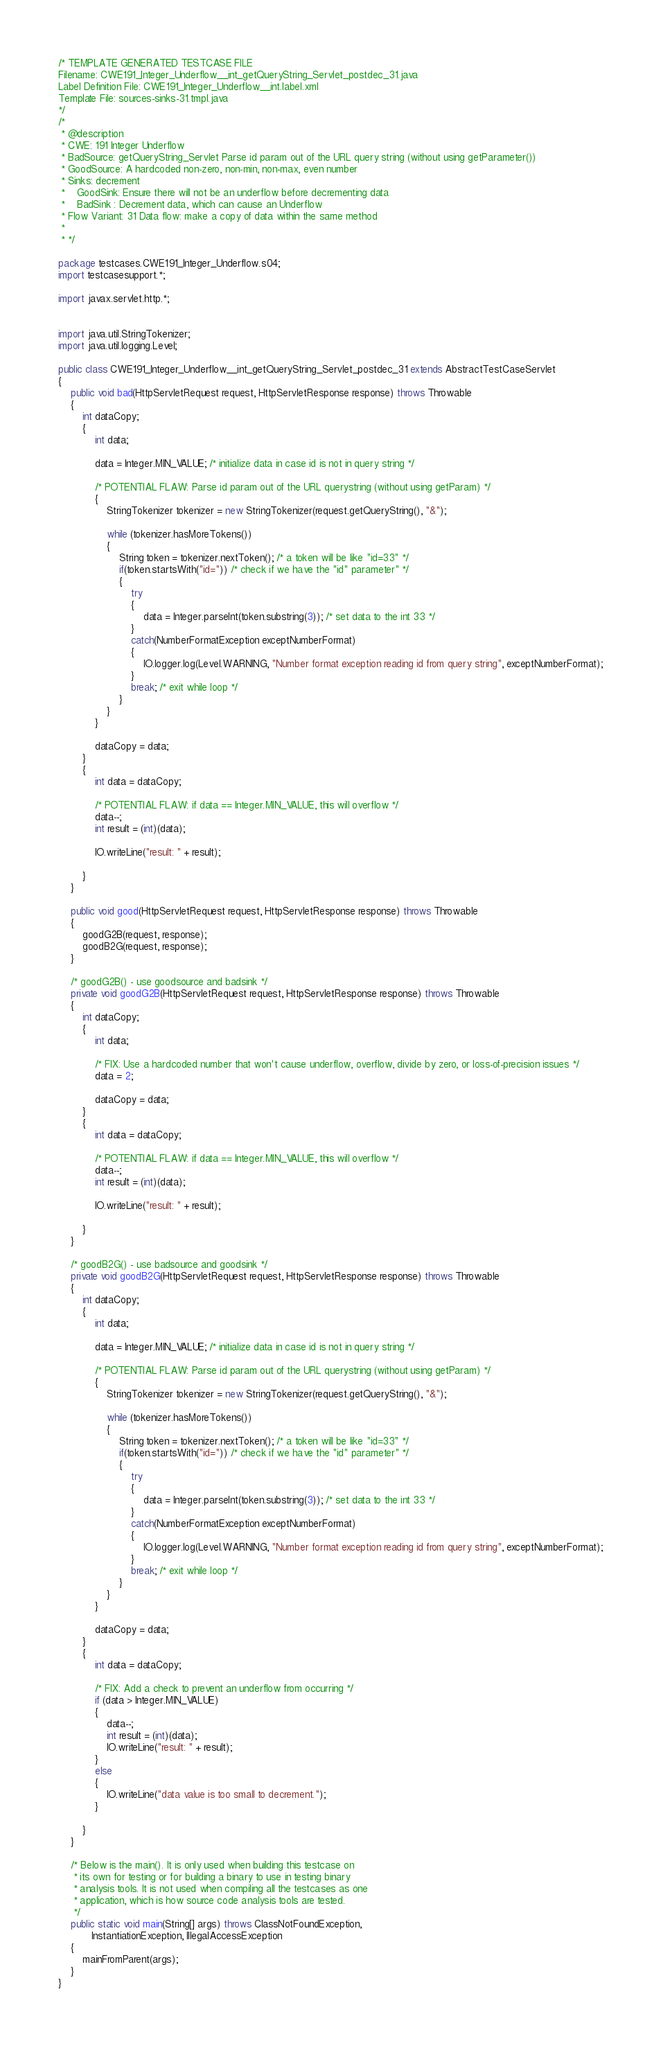<code> <loc_0><loc_0><loc_500><loc_500><_Java_>/* TEMPLATE GENERATED TESTCASE FILE
Filename: CWE191_Integer_Underflow__int_getQueryString_Servlet_postdec_31.java
Label Definition File: CWE191_Integer_Underflow__int.label.xml
Template File: sources-sinks-31.tmpl.java
*/
/*
 * @description
 * CWE: 191 Integer Underflow
 * BadSource: getQueryString_Servlet Parse id param out of the URL query string (without using getParameter())
 * GoodSource: A hardcoded non-zero, non-min, non-max, even number
 * Sinks: decrement
 *    GoodSink: Ensure there will not be an underflow before decrementing data
 *    BadSink : Decrement data, which can cause an Underflow
 * Flow Variant: 31 Data flow: make a copy of data within the same method
 *
 * */

package testcases.CWE191_Integer_Underflow.s04;
import testcasesupport.*;

import javax.servlet.http.*;


import java.util.StringTokenizer;
import java.util.logging.Level;

public class CWE191_Integer_Underflow__int_getQueryString_Servlet_postdec_31 extends AbstractTestCaseServlet
{
    public void bad(HttpServletRequest request, HttpServletResponse response) throws Throwable
    {
        int dataCopy;
        {
            int data;

            data = Integer.MIN_VALUE; /* initialize data in case id is not in query string */

            /* POTENTIAL FLAW: Parse id param out of the URL querystring (without using getParam) */
            {
                StringTokenizer tokenizer = new StringTokenizer(request.getQueryString(), "&");

                while (tokenizer.hasMoreTokens())
                {
                    String token = tokenizer.nextToken(); /* a token will be like "id=33" */
                    if(token.startsWith("id=")) /* check if we have the "id" parameter" */
                    {
                        try
                        {
                            data = Integer.parseInt(token.substring(3)); /* set data to the int 33 */
                        }
                        catch(NumberFormatException exceptNumberFormat)
                        {
                            IO.logger.log(Level.WARNING, "Number format exception reading id from query string", exceptNumberFormat);
                        }
                        break; /* exit while loop */
                    }
                }
            }

            dataCopy = data;
        }
        {
            int data = dataCopy;

            /* POTENTIAL FLAW: if data == Integer.MIN_VALUE, this will overflow */
            data--;
            int result = (int)(data);

            IO.writeLine("result: " + result);

        }
    }

    public void good(HttpServletRequest request, HttpServletResponse response) throws Throwable
    {
        goodG2B(request, response);
        goodB2G(request, response);
    }

    /* goodG2B() - use goodsource and badsink */
    private void goodG2B(HttpServletRequest request, HttpServletResponse response) throws Throwable
    {
        int dataCopy;
        {
            int data;

            /* FIX: Use a hardcoded number that won't cause underflow, overflow, divide by zero, or loss-of-precision issues */
            data = 2;

            dataCopy = data;
        }
        {
            int data = dataCopy;

            /* POTENTIAL FLAW: if data == Integer.MIN_VALUE, this will overflow */
            data--;
            int result = (int)(data);

            IO.writeLine("result: " + result);

        }
    }

    /* goodB2G() - use badsource and goodsink */
    private void goodB2G(HttpServletRequest request, HttpServletResponse response) throws Throwable
    {
        int dataCopy;
        {
            int data;

            data = Integer.MIN_VALUE; /* initialize data in case id is not in query string */

            /* POTENTIAL FLAW: Parse id param out of the URL querystring (without using getParam) */
            {
                StringTokenizer tokenizer = new StringTokenizer(request.getQueryString(), "&");

                while (tokenizer.hasMoreTokens())
                {
                    String token = tokenizer.nextToken(); /* a token will be like "id=33" */
                    if(token.startsWith("id=")) /* check if we have the "id" parameter" */
                    {
                        try
                        {
                            data = Integer.parseInt(token.substring(3)); /* set data to the int 33 */
                        }
                        catch(NumberFormatException exceptNumberFormat)
                        {
                            IO.logger.log(Level.WARNING, "Number format exception reading id from query string", exceptNumberFormat);
                        }
                        break; /* exit while loop */
                    }
                }
            }

            dataCopy = data;
        }
        {
            int data = dataCopy;

            /* FIX: Add a check to prevent an underflow from occurring */
            if (data > Integer.MIN_VALUE)
            {
                data--;
                int result = (int)(data);
                IO.writeLine("result: " + result);
            }
            else
            {
                IO.writeLine("data value is too small to decrement.");
            }

        }
    }

    /* Below is the main(). It is only used when building this testcase on
     * its own for testing or for building a binary to use in testing binary
     * analysis tools. It is not used when compiling all the testcases as one
     * application, which is how source code analysis tools are tested.
     */
    public static void main(String[] args) throws ClassNotFoundException,
           InstantiationException, IllegalAccessException
    {
        mainFromParent(args);
    }
}
</code> 